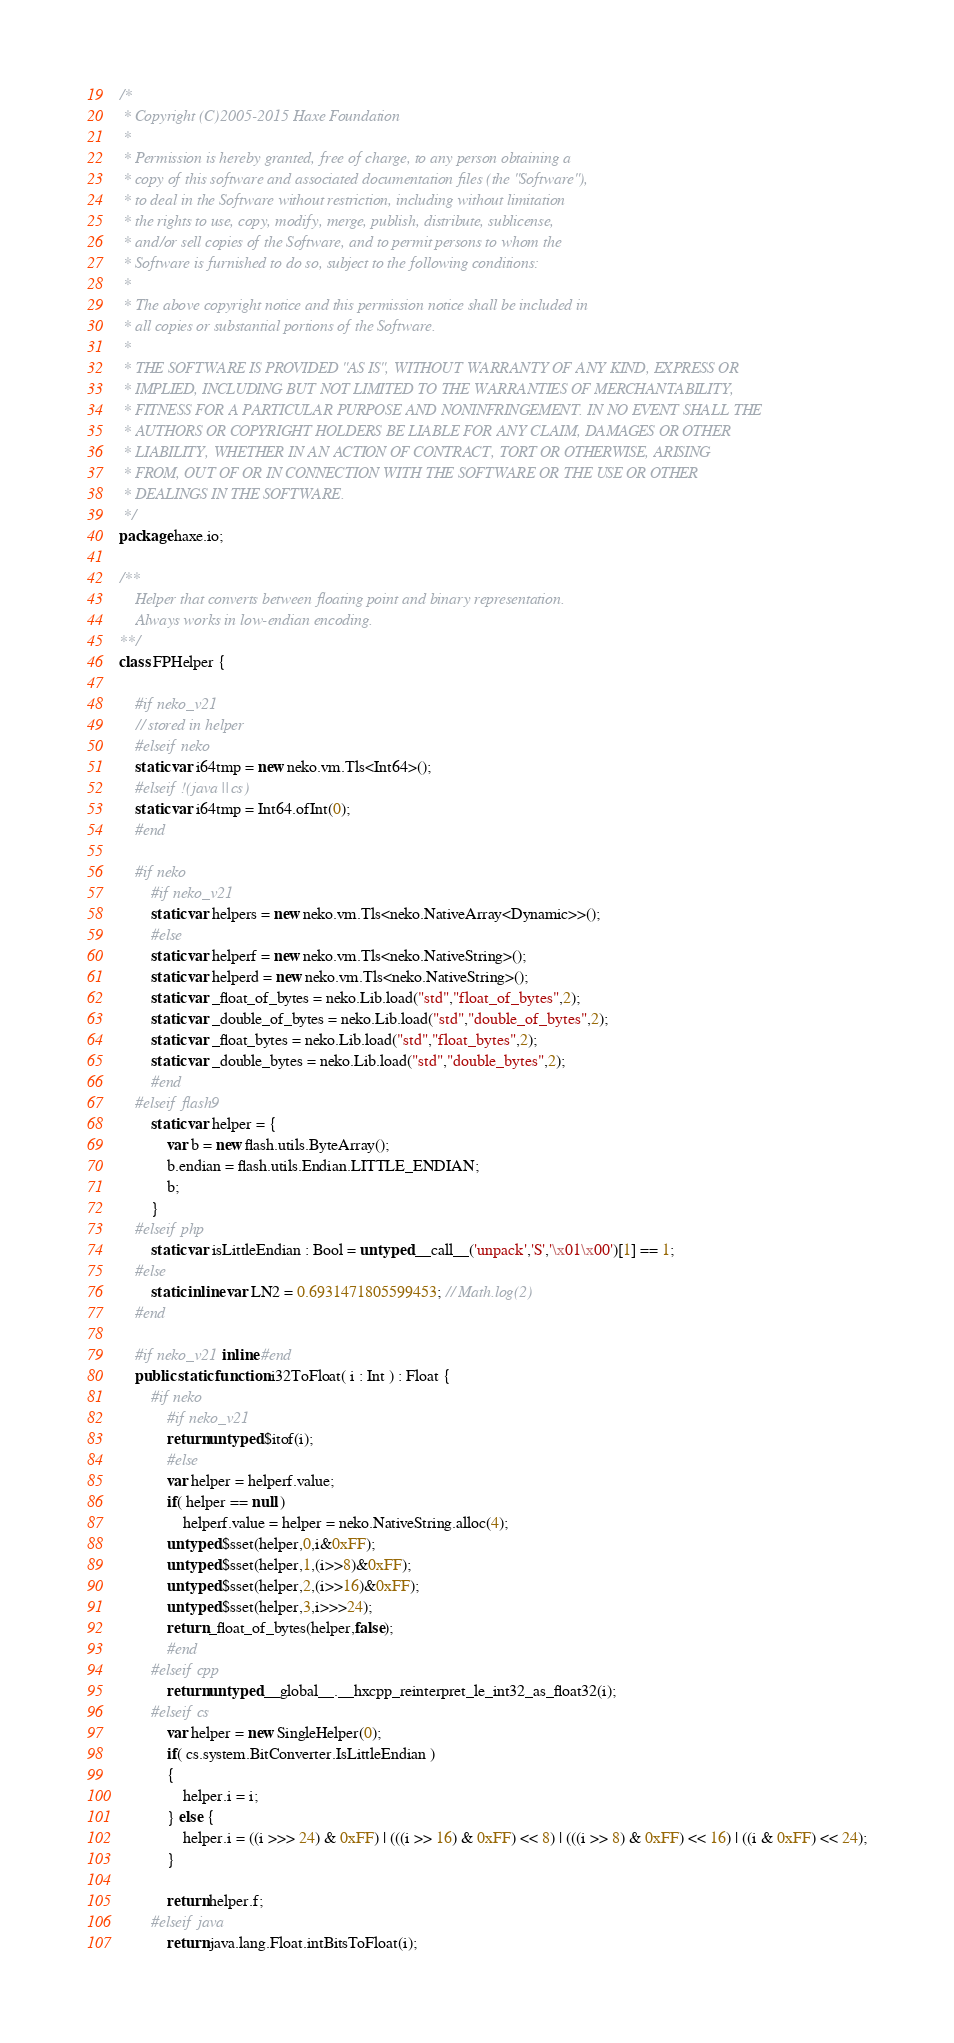Convert code to text. <code><loc_0><loc_0><loc_500><loc_500><_Haxe_>/*
 * Copyright (C)2005-2015 Haxe Foundation
 *
 * Permission is hereby granted, free of charge, to any person obtaining a
 * copy of this software and associated documentation files (the "Software"),
 * to deal in the Software without restriction, including without limitation
 * the rights to use, copy, modify, merge, publish, distribute, sublicense,
 * and/or sell copies of the Software, and to permit persons to whom the
 * Software is furnished to do so, subject to the following conditions:
 *
 * The above copyright notice and this permission notice shall be included in
 * all copies or substantial portions of the Software.
 *
 * THE SOFTWARE IS PROVIDED "AS IS", WITHOUT WARRANTY OF ANY KIND, EXPRESS OR
 * IMPLIED, INCLUDING BUT NOT LIMITED TO THE WARRANTIES OF MERCHANTABILITY,
 * FITNESS FOR A PARTICULAR PURPOSE AND NONINFRINGEMENT. IN NO EVENT SHALL THE
 * AUTHORS OR COPYRIGHT HOLDERS BE LIABLE FOR ANY CLAIM, DAMAGES OR OTHER
 * LIABILITY, WHETHER IN AN ACTION OF CONTRACT, TORT OR OTHERWISE, ARISING
 * FROM, OUT OF OR IN CONNECTION WITH THE SOFTWARE OR THE USE OR OTHER
 * DEALINGS IN THE SOFTWARE.
 */
package haxe.io;

/**
	Helper that converts between floating point and binary representation.
	Always works in low-endian encoding.
**/
class FPHelper {

	#if neko_v21
	// stored in helper
	#elseif neko
	static var i64tmp = new neko.vm.Tls<Int64>();
	#elseif !(java || cs)
	static var i64tmp = Int64.ofInt(0);
	#end

	#if neko
		#if neko_v21
		static var helpers = new neko.vm.Tls<neko.NativeArray<Dynamic>>();
		#else
		static var helperf = new neko.vm.Tls<neko.NativeString>();
		static var helperd = new neko.vm.Tls<neko.NativeString>();
		static var _float_of_bytes = neko.Lib.load("std","float_of_bytes",2);
		static var _double_of_bytes = neko.Lib.load("std","double_of_bytes",2);
		static var _float_bytes = neko.Lib.load("std","float_bytes",2);
		static var _double_bytes = neko.Lib.load("std","double_bytes",2);
		#end
	#elseif flash9
		static var helper = {
			var b = new flash.utils.ByteArray();
			b.endian = flash.utils.Endian.LITTLE_ENDIAN;
			b;
		}
	#elseif php
		static var isLittleEndian : Bool = untyped __call__('unpack','S','\x01\x00')[1] == 1;
	#else
		static inline var LN2 = 0.6931471805599453; // Math.log(2)
	#end

	#if neko_v21 inline #end
	public static function i32ToFloat( i : Int ) : Float {
		#if neko
			#if neko_v21
			return untyped $itof(i);
			#else
			var helper = helperf.value;
			if( helper == null )
				helperf.value = helper = neko.NativeString.alloc(4);
			untyped $sset(helper,0,i&0xFF);
			untyped $sset(helper,1,(i>>8)&0xFF);
			untyped $sset(helper,2,(i>>16)&0xFF);
			untyped $sset(helper,3,i>>>24);
			return _float_of_bytes(helper,false);
			#end
		#elseif cpp
			return untyped __global__.__hxcpp_reinterpret_le_int32_as_float32(i);
		#elseif cs
			var helper = new SingleHelper(0);
			if( cs.system.BitConverter.IsLittleEndian )
			{
				helper.i = i;
			} else {
				helper.i = ((i >>> 24) & 0xFF) | (((i >> 16) & 0xFF) << 8) | (((i >> 8) & 0xFF) << 16) | ((i & 0xFF) << 24);
			}

			return helper.f;
		#elseif java
			return java.lang.Float.intBitsToFloat(i);</code> 